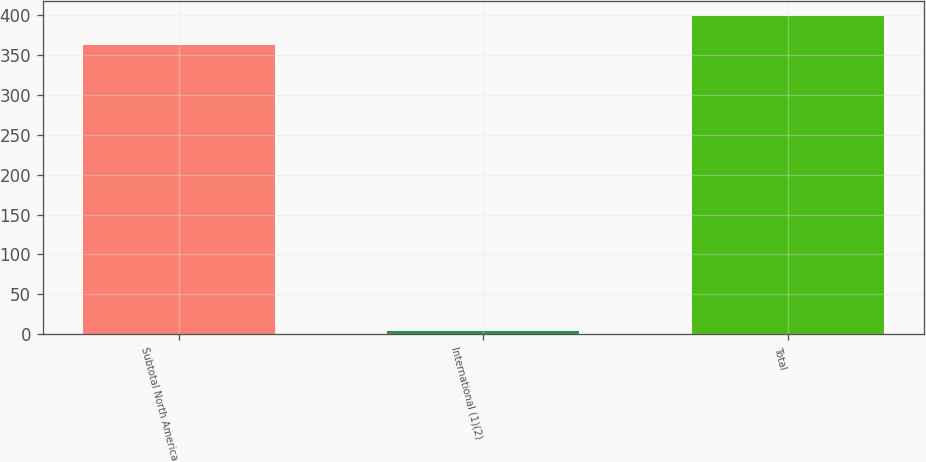Convert chart to OTSL. <chart><loc_0><loc_0><loc_500><loc_500><bar_chart><fcel>Subtotal North America<fcel>International (1)(2)<fcel>Total<nl><fcel>362<fcel>4<fcel>398.2<nl></chart> 